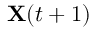<formula> <loc_0><loc_0><loc_500><loc_500>X ( t + 1 )</formula> 